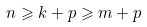Convert formula to latex. <formula><loc_0><loc_0><loc_500><loc_500>n \geqslant k + p \geqslant m + p</formula> 